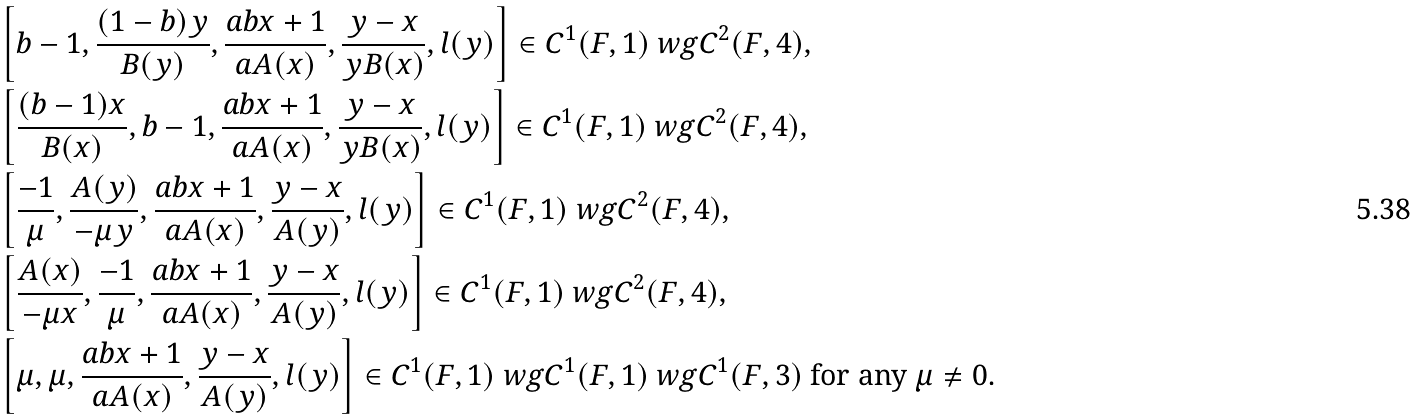Convert formula to latex. <formula><loc_0><loc_0><loc_500><loc_500>\ & \left [ b - 1 , \frac { ( 1 - b ) y } { B ( y ) } , \frac { a b x + 1 } { a A ( x ) } , \frac { y - x } { y B ( x ) } , l ( y ) \right ] \in C ^ { 1 } ( F , 1 ) \ w g C ^ { 2 } ( F , 4 ) , \\ \ & \left [ \frac { ( b - 1 ) x } { B ( x ) } , b - 1 , \frac { a b x + 1 } { a A ( x ) } , \frac { y - x } { y B ( x ) } , l ( y ) \right ] \in C ^ { 1 } ( F , 1 ) \ w g C ^ { 2 } ( F , 4 ) , \\ \ & \left [ \frac { - 1 } { \mu } , \frac { A ( y ) } { - \mu y } , \frac { a b x + 1 } { a A ( x ) } , \frac { y - x } { A ( y ) } , l ( y ) \right ] \in C ^ { 1 } ( F , 1 ) \ w g C ^ { 2 } ( F , 4 ) , \\ \ & \left [ \frac { A ( x ) } { - \mu x } , \frac { - 1 } { \mu } , \frac { a b x + 1 } { a A ( x ) } , \frac { y - x } { A ( y ) } , l ( y ) \right ] \in C ^ { 1 } ( F , 1 ) \ w g C ^ { 2 } ( F , 4 ) , \\ \ & \left [ \mu , \mu , \frac { a b x + 1 } { a A ( x ) } , \frac { y - x } { A ( y ) } , l ( y ) \right ] \in C ^ { 1 } ( F , 1 ) \ w g C ^ { 1 } ( F , 1 ) \ w g C ^ { 1 } ( F , 3 ) \ \text {for any } \mu \ne 0 .</formula> 